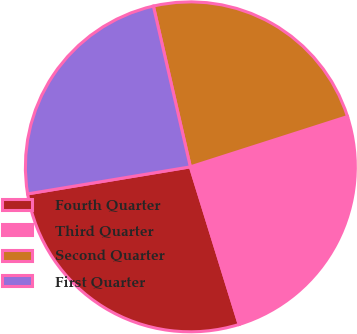Convert chart. <chart><loc_0><loc_0><loc_500><loc_500><pie_chart><fcel>Fourth Quarter<fcel>Third Quarter<fcel>Second Quarter<fcel>First Quarter<nl><fcel>27.16%<fcel>25.15%<fcel>23.67%<fcel>24.02%<nl></chart> 